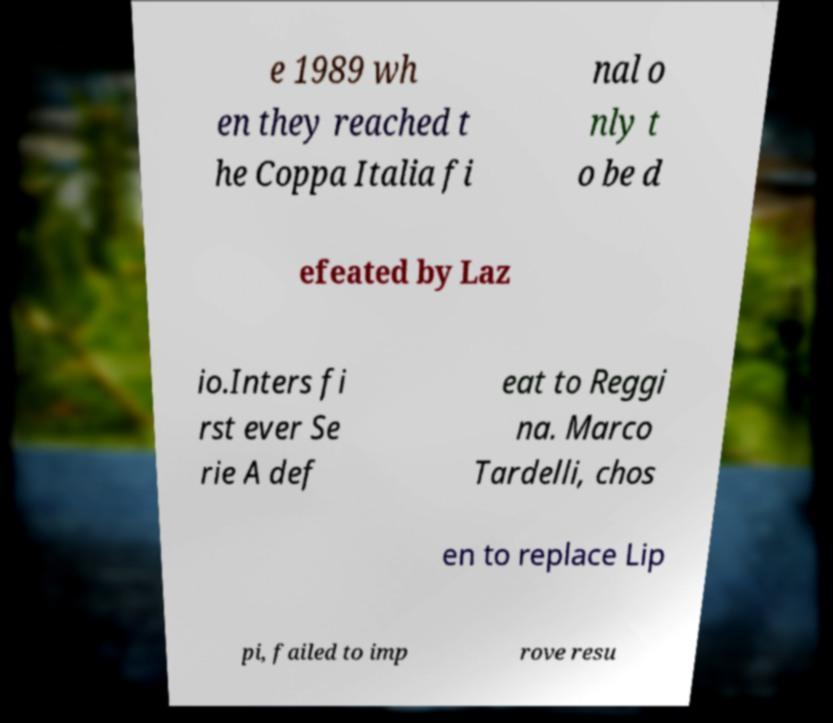Can you accurately transcribe the text from the provided image for me? e 1989 wh en they reached t he Coppa Italia fi nal o nly t o be d efeated by Laz io.Inters fi rst ever Se rie A def eat to Reggi na. Marco Tardelli, chos en to replace Lip pi, failed to imp rove resu 